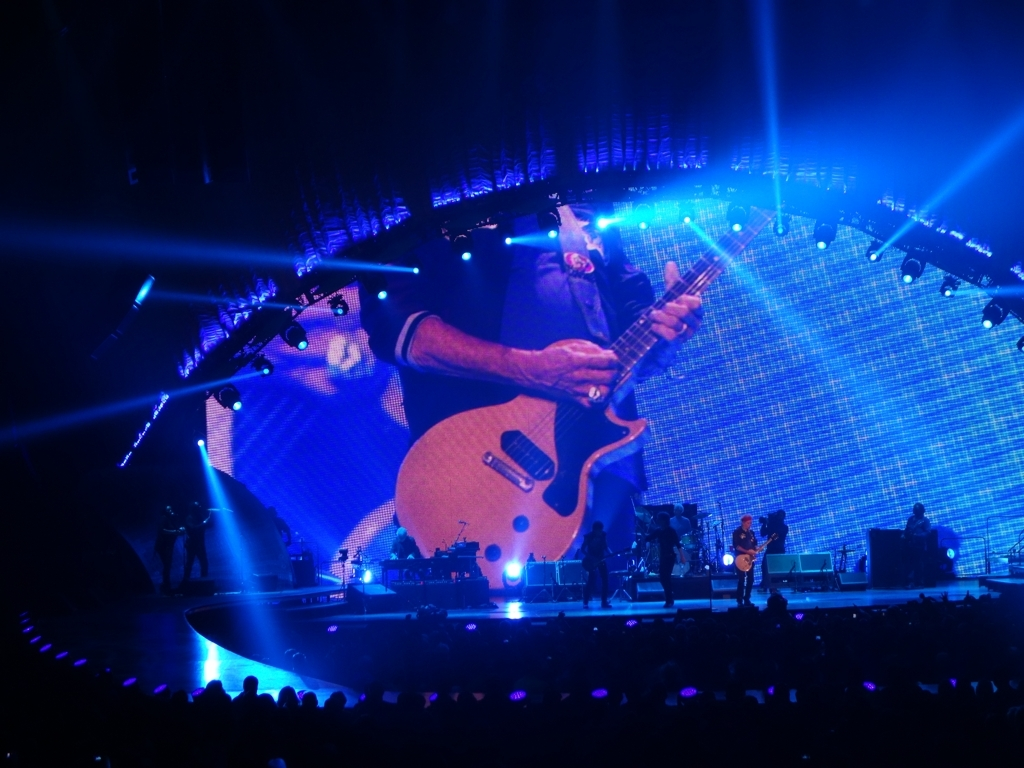Can you describe the lighting and visual effects used on stage? The stage is bathed in vibrant blue lights with rays beaming outward from the center, complementing the musician's silhouette. A large, illuminated screen behind the artist displays magnified visuals that enhance the overall spectacle and dynamic feel of the concert. How does the onscreen visual contribute to the performance? The oversized onscreen visual acts as a dramatic backdrop, magnifying the performer's presence and creating a sense of immersion for the audience. It's a powerful visual technique that adds to the entertainment factor and helps establish a strong connection between the performer and the crowd. 